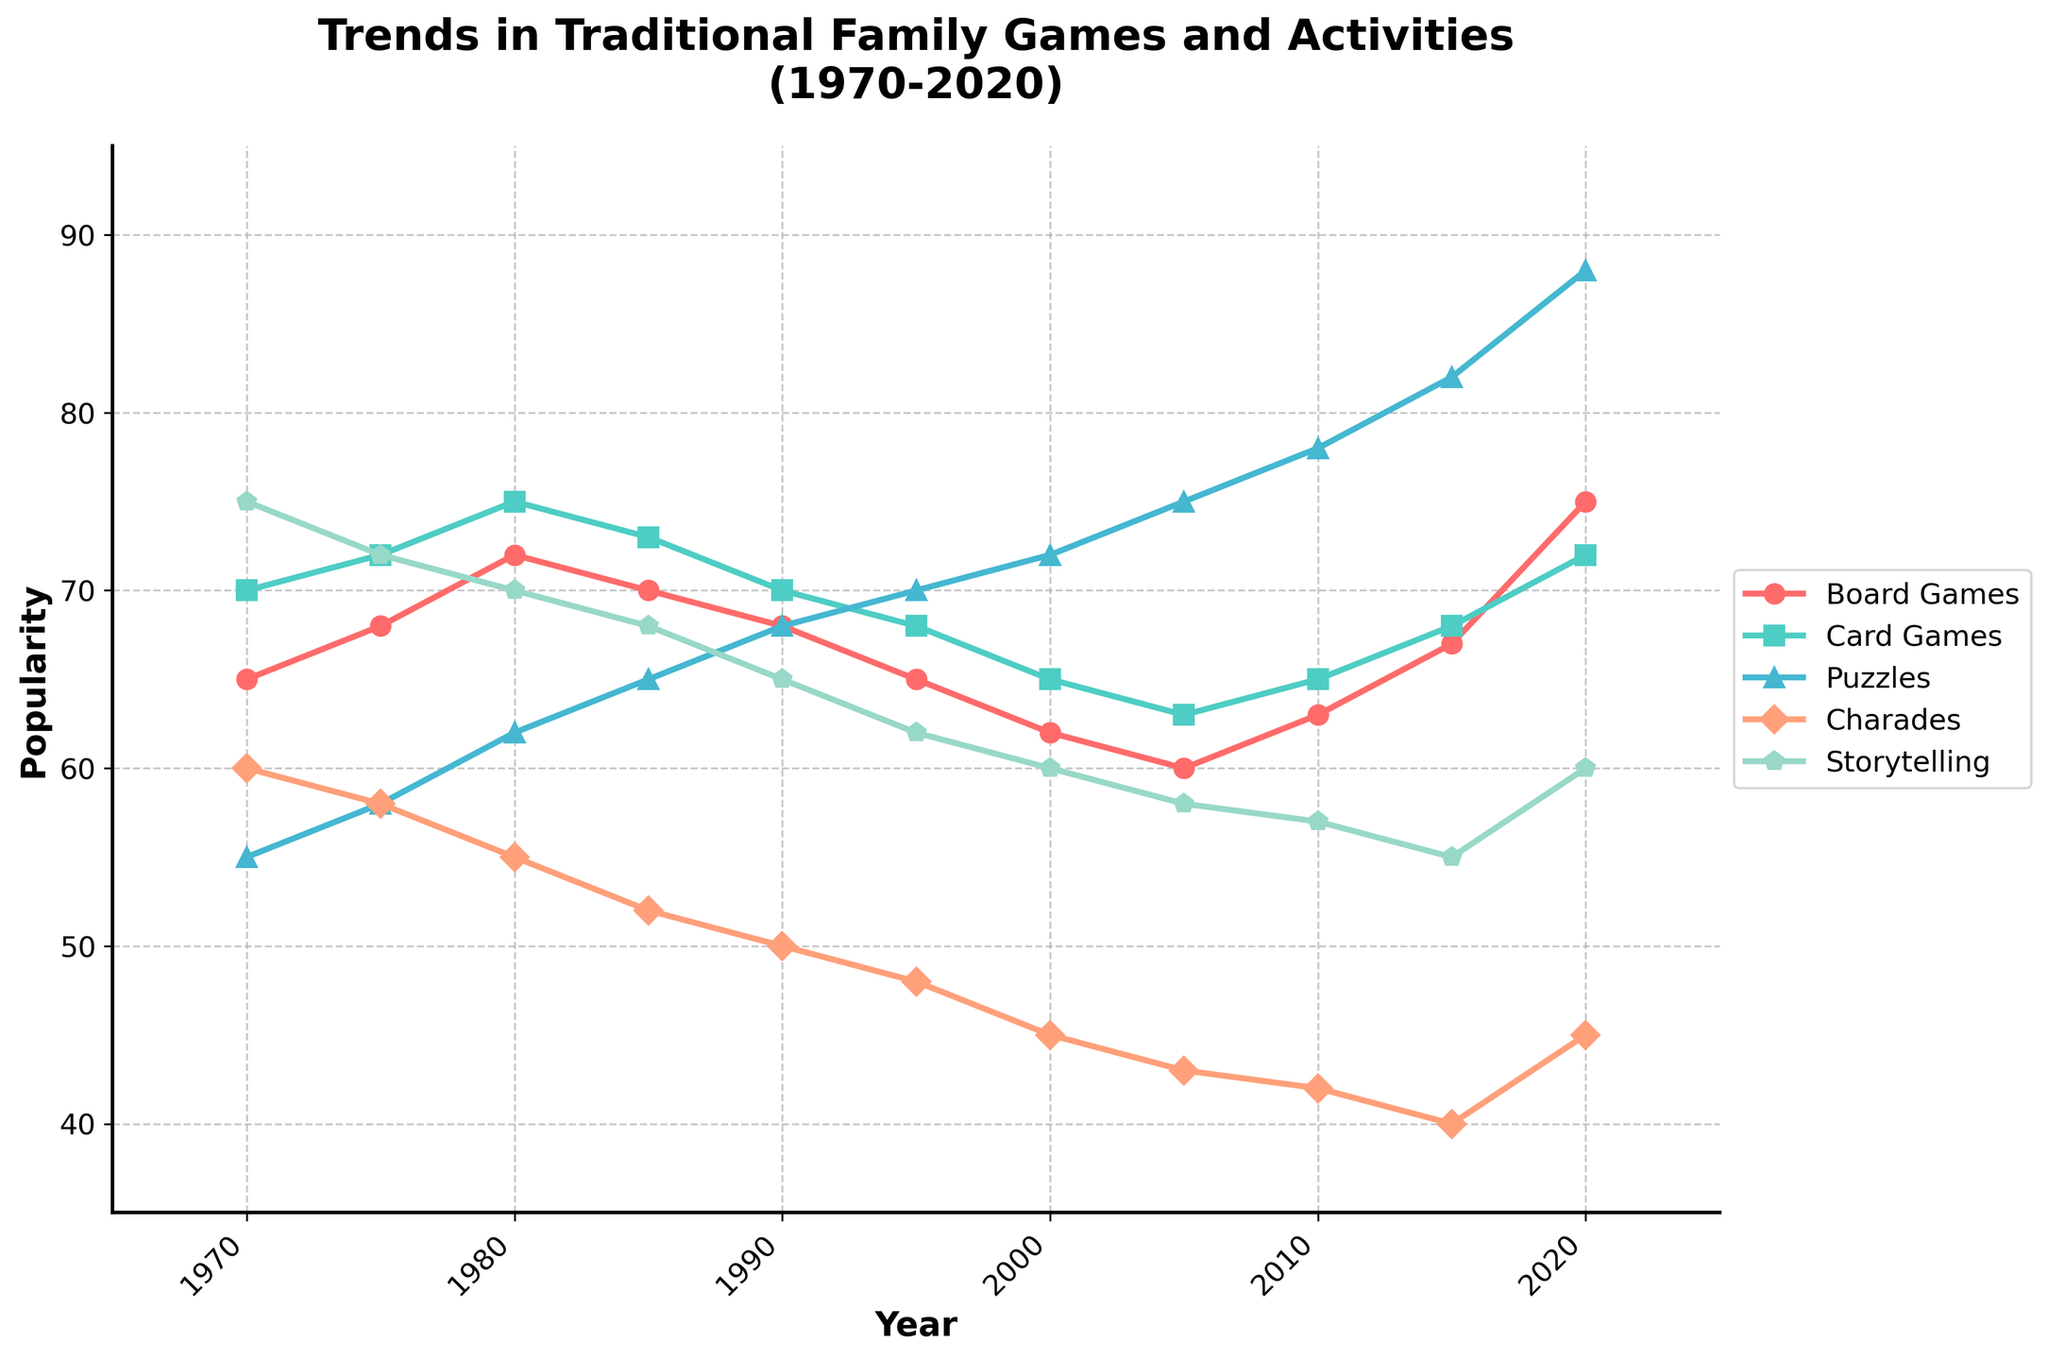Which family game had the highest popularity in 2020? Looking at the data lines for each game in the year 2020, the highest value is for Puzzles at 88.
Answer: Puzzles How did the popularity of Charades change from 1970 to 2020? The popularity of Charades started at 60 in 1970 and decreased to 45 in 2020.
Answer: Decrease Which two family games had the same popularity in any given year? In 1980 and 1990, Board Games and Card Games both had the same popularity: 75 in 1980 and 70 in 1990.
Answer: Board Games and Card Games What is the overall trend in the popularity of Board Games from 1970 to 2020? The popularity of Board Games slightly increases from 65 in 1970 to 75 in 2020 but had some fluctuations in between.
Answer: Fluctuating within a increasing trend Compare the trend of Storytelling and Puzzles from 1970 to 2020. Storytelling shows a decreasing trend from 75 in 1970 to 60 in 2020, while Puzzles show an increasing trend from 55 in 1970 to 88 in 2020.
Answer: Storytelling decreases, Puzzles increase Between which two consecutive decades did Puzzles experience the sharpest increase in popularity? The sharpest increase for Puzzles is between 2010 and 2015, increasing from 78 to 82.
Answer: 2010 to 2015 What is the average popularity of all the activities in the year 2000? Sum of the popularity values in 2000 is 62+65+72+45+60 = 304. With 5 activities, the average is 304/5 = 60.8.
Answer: 60.8 Which game had a higher popularity in 1995, Charades or Puzzles? In 1995, Charades had a popularity of 48 while Puzzles had 70.
Answer: Puzzles Which activity had the most consistent (almost flat) line across the decades? Card Games had the most consistent popularity ranging between 63 and 75 without significant changes.
Answer: Card Games 